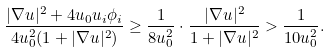<formula> <loc_0><loc_0><loc_500><loc_500>\frac { | \nabla u | ^ { 2 } + 4 u _ { 0 } u _ { i } \phi _ { i } } { 4 u _ { 0 } ^ { 2 } ( 1 + | \nabla u | ^ { 2 } ) } \geq \frac { 1 } { 8 u _ { 0 } ^ { 2 } } \cdot \frac { | \nabla u | ^ { 2 } } { 1 + | \nabla u | ^ { 2 } } > \frac { 1 } { 1 0 u _ { 0 } ^ { 2 } } .</formula> 